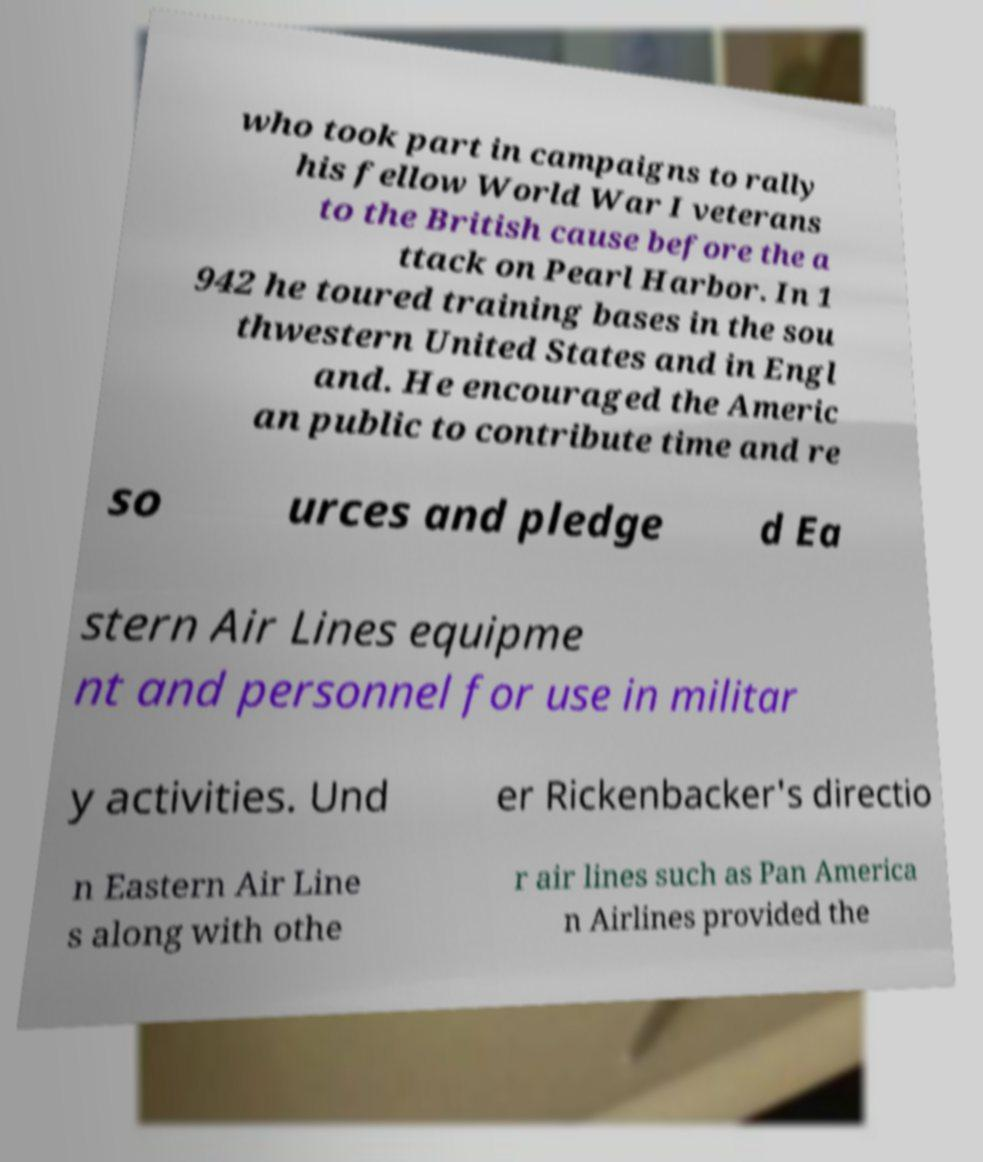Can you read and provide the text displayed in the image?This photo seems to have some interesting text. Can you extract and type it out for me? who took part in campaigns to rally his fellow World War I veterans to the British cause before the a ttack on Pearl Harbor. In 1 942 he toured training bases in the sou thwestern United States and in Engl and. He encouraged the Americ an public to contribute time and re so urces and pledge d Ea stern Air Lines equipme nt and personnel for use in militar y activities. Und er Rickenbacker's directio n Eastern Air Line s along with othe r air lines such as Pan America n Airlines provided the 